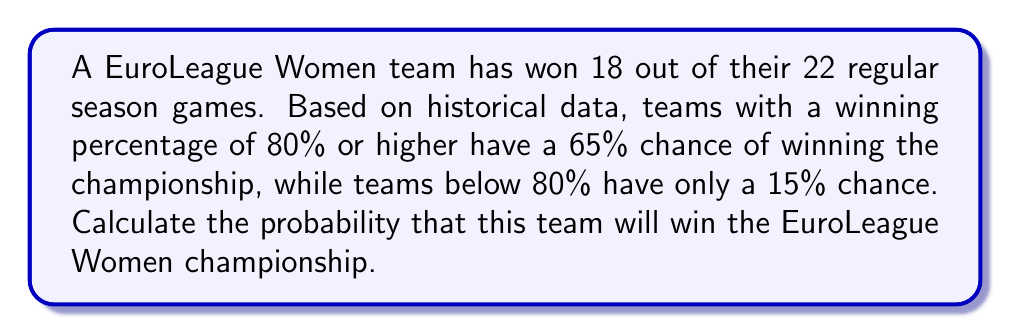Can you answer this question? To solve this problem, we need to follow these steps:

1. Calculate the team's winning percentage:
   $$\text{Winning Percentage} = \frac{\text{Games Won}}{\text{Total Games}} \times 100\%$$
   $$\text{Winning Percentage} = \frac{18}{22} \times 100\% = 81.82\%$$

2. Determine which probability category the team falls into:
   Since 81.82% > 80%, the team falls into the category with a 65% chance of winning the championship.

3. The probability of the team winning the championship is therefore 65% or 0.65.

This can be expressed mathematically as:

$$P(\text{Winning Championship}) = 0.65$$
Answer: The probability that this team will win the EuroLeague Women championship is 0.65 or 65%. 